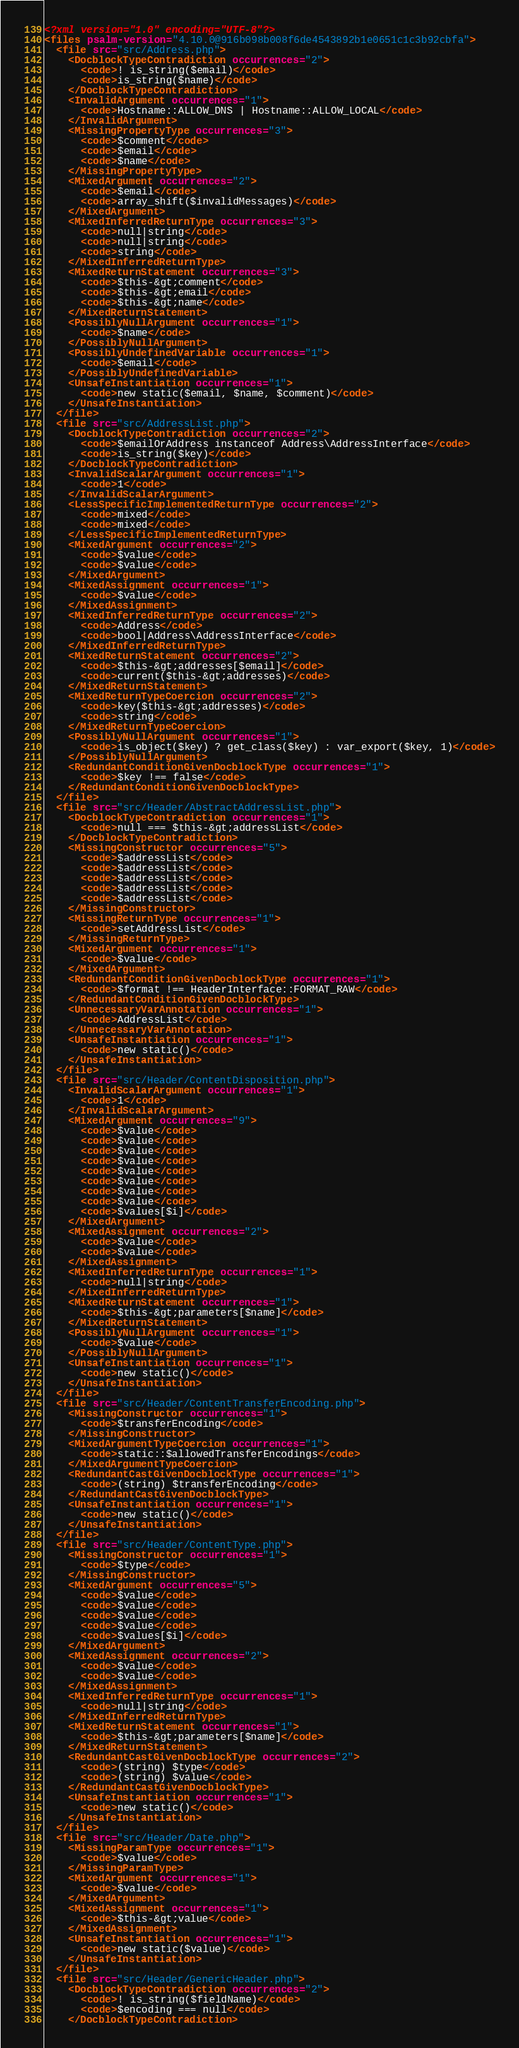<code> <loc_0><loc_0><loc_500><loc_500><_XML_><?xml version="1.0" encoding="UTF-8"?>
<files psalm-version="4.10.0@916b098b008f6de4543892b1e0651c1c3b92cbfa">
  <file src="src/Address.php">
    <DocblockTypeContradiction occurrences="2">
      <code>! is_string($email)</code>
      <code>is_string($name)</code>
    </DocblockTypeContradiction>
    <InvalidArgument occurrences="1">
      <code>Hostname::ALLOW_DNS | Hostname::ALLOW_LOCAL</code>
    </InvalidArgument>
    <MissingPropertyType occurrences="3">
      <code>$comment</code>
      <code>$email</code>
      <code>$name</code>
    </MissingPropertyType>
    <MixedArgument occurrences="2">
      <code>$email</code>
      <code>array_shift($invalidMessages)</code>
    </MixedArgument>
    <MixedInferredReturnType occurrences="3">
      <code>null|string</code>
      <code>null|string</code>
      <code>string</code>
    </MixedInferredReturnType>
    <MixedReturnStatement occurrences="3">
      <code>$this-&gt;comment</code>
      <code>$this-&gt;email</code>
      <code>$this-&gt;name</code>
    </MixedReturnStatement>
    <PossiblyNullArgument occurrences="1">
      <code>$name</code>
    </PossiblyNullArgument>
    <PossiblyUndefinedVariable occurrences="1">
      <code>$email</code>
    </PossiblyUndefinedVariable>
    <UnsafeInstantiation occurrences="1">
      <code>new static($email, $name, $comment)</code>
    </UnsafeInstantiation>
  </file>
  <file src="src/AddressList.php">
    <DocblockTypeContradiction occurrences="2">
      <code>$emailOrAddress instanceof Address\AddressInterface</code>
      <code>is_string($key)</code>
    </DocblockTypeContradiction>
    <InvalidScalarArgument occurrences="1">
      <code>1</code>
    </InvalidScalarArgument>
    <LessSpecificImplementedReturnType occurrences="2">
      <code>mixed</code>
      <code>mixed</code>
    </LessSpecificImplementedReturnType>
    <MixedArgument occurrences="2">
      <code>$value</code>
      <code>$value</code>
    </MixedArgument>
    <MixedAssignment occurrences="1">
      <code>$value</code>
    </MixedAssignment>
    <MixedInferredReturnType occurrences="2">
      <code>Address</code>
      <code>bool|Address\AddressInterface</code>
    </MixedInferredReturnType>
    <MixedReturnStatement occurrences="2">
      <code>$this-&gt;addresses[$email]</code>
      <code>current($this-&gt;addresses)</code>
    </MixedReturnStatement>
    <MixedReturnTypeCoercion occurrences="2">
      <code>key($this-&gt;addresses)</code>
      <code>string</code>
    </MixedReturnTypeCoercion>
    <PossiblyNullArgument occurrences="1">
      <code>is_object($key) ? get_class($key) : var_export($key, 1)</code>
    </PossiblyNullArgument>
    <RedundantConditionGivenDocblockType occurrences="1">
      <code>$key !== false</code>
    </RedundantConditionGivenDocblockType>
  </file>
  <file src="src/Header/AbstractAddressList.php">
    <DocblockTypeContradiction occurrences="1">
      <code>null === $this-&gt;addressList</code>
    </DocblockTypeContradiction>
    <MissingConstructor occurrences="5">
      <code>$addressList</code>
      <code>$addressList</code>
      <code>$addressList</code>
      <code>$addressList</code>
      <code>$addressList</code>
    </MissingConstructor>
    <MissingReturnType occurrences="1">
      <code>setAddressList</code>
    </MissingReturnType>
    <MixedArgument occurrences="1">
      <code>$value</code>
    </MixedArgument>
    <RedundantConditionGivenDocblockType occurrences="1">
      <code>$format !== HeaderInterface::FORMAT_RAW</code>
    </RedundantConditionGivenDocblockType>
    <UnnecessaryVarAnnotation occurrences="1">
      <code>AddressList</code>
    </UnnecessaryVarAnnotation>
    <UnsafeInstantiation occurrences="1">
      <code>new static()</code>
    </UnsafeInstantiation>
  </file>
  <file src="src/Header/ContentDisposition.php">
    <InvalidScalarArgument occurrences="1">
      <code>1</code>
    </InvalidScalarArgument>
    <MixedArgument occurrences="9">
      <code>$value</code>
      <code>$value</code>
      <code>$value</code>
      <code>$value</code>
      <code>$value</code>
      <code>$value</code>
      <code>$value</code>
      <code>$value</code>
      <code>$values[$i]</code>
    </MixedArgument>
    <MixedAssignment occurrences="2">
      <code>$value</code>
      <code>$value</code>
    </MixedAssignment>
    <MixedInferredReturnType occurrences="1">
      <code>null|string</code>
    </MixedInferredReturnType>
    <MixedReturnStatement occurrences="1">
      <code>$this-&gt;parameters[$name]</code>
    </MixedReturnStatement>
    <PossiblyNullArgument occurrences="1">
      <code>$value</code>
    </PossiblyNullArgument>
    <UnsafeInstantiation occurrences="1">
      <code>new static()</code>
    </UnsafeInstantiation>
  </file>
  <file src="src/Header/ContentTransferEncoding.php">
    <MissingConstructor occurrences="1">
      <code>$transferEncoding</code>
    </MissingConstructor>
    <MixedArgumentTypeCoercion occurrences="1">
      <code>static::$allowedTransferEncodings</code>
    </MixedArgumentTypeCoercion>
    <RedundantCastGivenDocblockType occurrences="1">
      <code>(string) $transferEncoding</code>
    </RedundantCastGivenDocblockType>
    <UnsafeInstantiation occurrences="1">
      <code>new static()</code>
    </UnsafeInstantiation>
  </file>
  <file src="src/Header/ContentType.php">
    <MissingConstructor occurrences="1">
      <code>$type</code>
    </MissingConstructor>
    <MixedArgument occurrences="5">
      <code>$value</code>
      <code>$value</code>
      <code>$value</code>
      <code>$value</code>
      <code>$values[$i]</code>
    </MixedArgument>
    <MixedAssignment occurrences="2">
      <code>$value</code>
      <code>$value</code>
    </MixedAssignment>
    <MixedInferredReturnType occurrences="1">
      <code>null|string</code>
    </MixedInferredReturnType>
    <MixedReturnStatement occurrences="1">
      <code>$this-&gt;parameters[$name]</code>
    </MixedReturnStatement>
    <RedundantCastGivenDocblockType occurrences="2">
      <code>(string) $type</code>
      <code>(string) $value</code>
    </RedundantCastGivenDocblockType>
    <UnsafeInstantiation occurrences="1">
      <code>new static()</code>
    </UnsafeInstantiation>
  </file>
  <file src="src/Header/Date.php">
    <MissingParamType occurrences="1">
      <code>$value</code>
    </MissingParamType>
    <MixedArgument occurrences="1">
      <code>$value</code>
    </MixedArgument>
    <MixedAssignment occurrences="1">
      <code>$this-&gt;value</code>
    </MixedAssignment>
    <UnsafeInstantiation occurrences="1">
      <code>new static($value)</code>
    </UnsafeInstantiation>
  </file>
  <file src="src/Header/GenericHeader.php">
    <DocblockTypeContradiction occurrences="2">
      <code>! is_string($fieldName)</code>
      <code>$encoding === null</code>
    </DocblockTypeContradiction></code> 